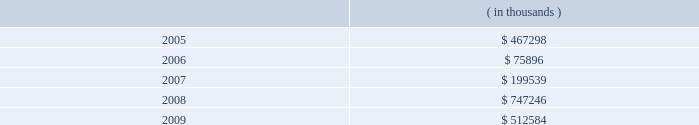Entergy corporation notes to consolidated financial statements the annual long-term debt maturities ( excluding lease obligations ) for debt outstanding as of december 31 , 2004 , for the next five years are as follows: .
In november 2000 , entergy's non-utility nuclear business purchased the fitzpatrick and indian point 3 power plants in a seller-financed transaction .
Entergy issued notes to nypa with seven annual installments of approximately $ 108 million commencing one year from the date of the closing , and eight annual installments of $ 20 million commencing eight years from the date of the closing .
These notes do not have a stated interest rate , but have an implicit interest rate of 4.8% ( 4.8 % ) .
In accordance with the purchase agreement with nypa , the purchase of indian point 2 in 2001 resulted in entergy's non-utility nuclear business becoming liable to nypa for an additional $ 10 million per year for 10 years , beginning in september 2003 .
This liability was recorded upon the purchase of indian point 2 in september 2001 , and is included in the note payable to nypa balance above .
In july 2003 , a payment of $ 102 million was made prior to maturity on the note payable to nypa .
Under a provision in a letter of credit supporting these notes , if certain of the domestic utility companies or system energy were to default on other indebtedness , entergy could be required to post collateral to support the letter of credit .
Covenants in the entergy corporation notes require it to maintain a consolidated debt ratio of 65% ( 65 % ) or less of its total capitalization .
If entergy's debt ratio exceeds this limit , or if entergy or certain of the domestic utility companies default on other indebtedness or are in bankruptcy or insolvency proceedings , an acceleration of the notes' maturity dates may occur .
The long-term securities issuances of entergy corporation , entergy gulf states , entergy louisiana , entergy mississippi , and system energy also are limited to amounts authorized by the sec .
Under its current sec order , and without further authorization , entergy corporation cannot incur additional indebtedness or issue other securities unless ( a ) it and each of its public utility subsidiaries maintain a common equity ratio of at least 30% ( 30 % ) and ( b ) the security to be issued ( if rated ) and all outstanding securities of entergy corporation that are rated , are rated investment grade by at least one nationally recognized statistical rating agency .
Under their current sec orders , and without further authorization , entergy gulf states , entergy louisiana , and entergy mississippi cannot incur additional indebtedness or issue other securities unless ( a ) the issuer and entergy corporation maintains a common equity ratio of at least 30% ( 30 % ) and ( b ) the security to be issued ( if rated ) and all outstanding securities of the issuer ( other than preferred stock of entergy gulf states ) , as well as all outstanding securities of entergy corporation , that are rated , are rated investment grade .
Junior subordinated deferrable interest debentures and implementation of fin 46 entergy implemented fasb interpretation no .
46 , "consolidation of variable interest entities" effective december 31 , 2003 .
Fin 46 requires existing unconsolidated variable interest entities to be consolidated by their primary beneficiaries if the entities do not effectively disperse risks among their investors .
Variable interest entities ( vies ) , generally , are entities that do not have sufficient equity to permit the entity to finance its operations without additional financial support from its equity interest holders and/or the group of equity interest holders are collectively not able to exercise control over the entity .
The primary beneficiary is the party that absorbs a majority of the entity's expected losses , receives a majority of its expected residual returns , or both as a result of holding the variable interest .
A company may have an interest in a vie through ownership or other contractual rights or obligations .
Entergy louisiana capital i , entergy arkansas capital i , and entergy gulf states capital i ( trusts ) were established as financing subsidiaries of entergy louisiana , entergy arkansas , and entergy gulf states .
What amount of long-term debt is due in the next 36 months for entergy corporation as of december 31 , 2004 , in millions? 
Computations: (((467298 + 75896) + 199539) / 1000)
Answer: 742.733. 